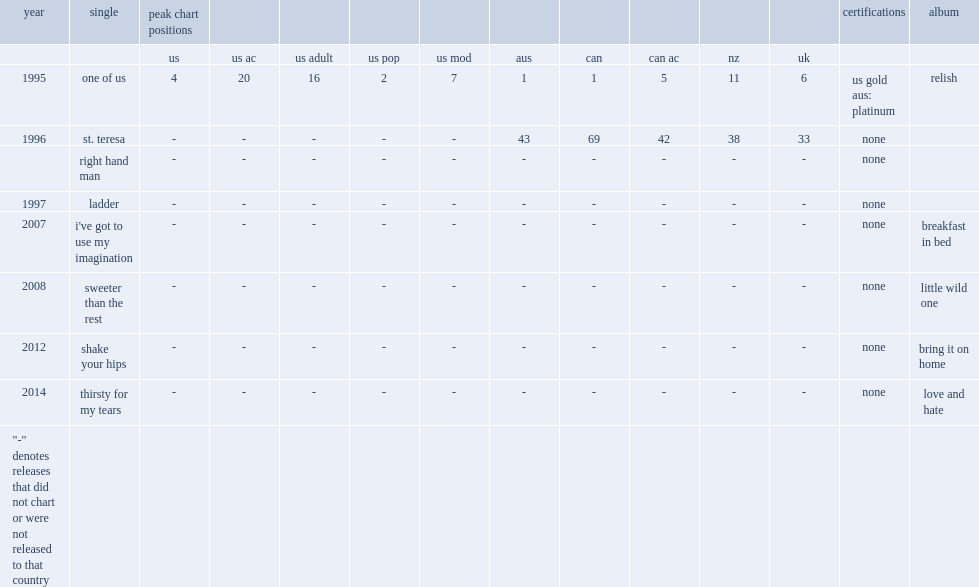In 1995, which album of joan osborne included the single "one of us"? Relish. 